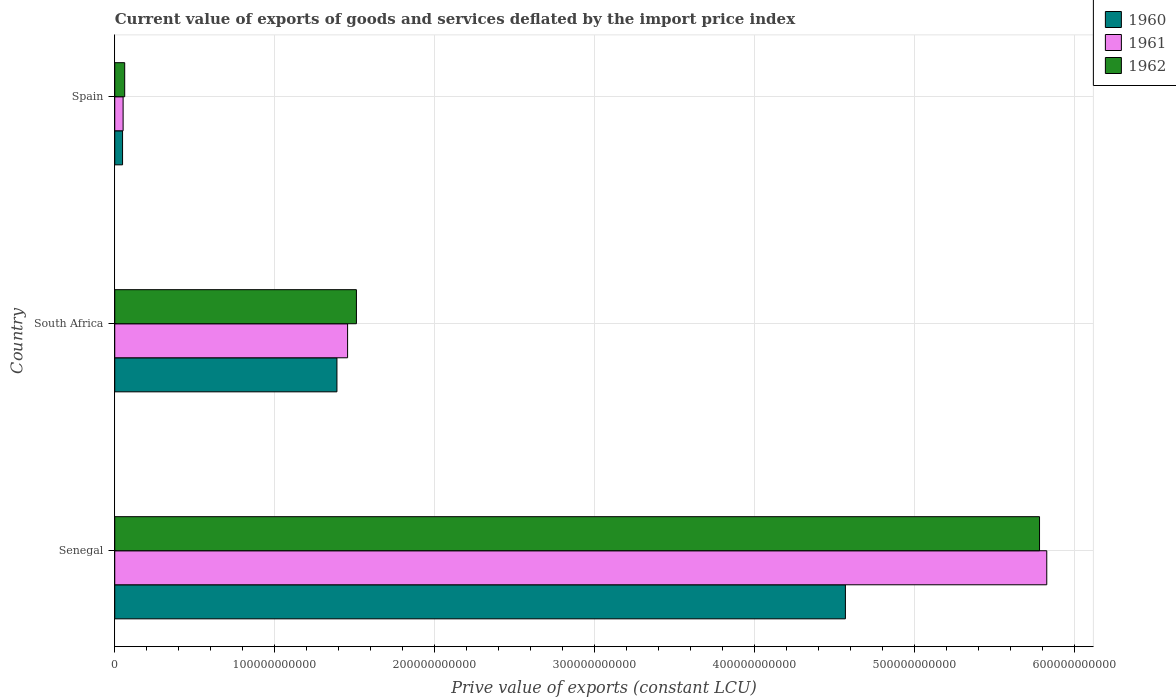How many different coloured bars are there?
Your response must be concise. 3. Are the number of bars per tick equal to the number of legend labels?
Offer a terse response. Yes. How many bars are there on the 3rd tick from the top?
Provide a succinct answer. 3. How many bars are there on the 2nd tick from the bottom?
Provide a succinct answer. 3. What is the label of the 3rd group of bars from the top?
Provide a short and direct response. Senegal. In how many cases, is the number of bars for a given country not equal to the number of legend labels?
Offer a terse response. 0. What is the prive value of exports in 1961 in Senegal?
Your response must be concise. 5.83e+11. Across all countries, what is the maximum prive value of exports in 1961?
Provide a short and direct response. 5.83e+11. Across all countries, what is the minimum prive value of exports in 1960?
Provide a succinct answer. 4.88e+09. In which country was the prive value of exports in 1961 maximum?
Provide a short and direct response. Senegal. In which country was the prive value of exports in 1960 minimum?
Your answer should be very brief. Spain. What is the total prive value of exports in 1961 in the graph?
Your answer should be compact. 7.34e+11. What is the difference between the prive value of exports in 1962 in South Africa and that in Spain?
Provide a succinct answer. 1.45e+11. What is the difference between the prive value of exports in 1962 in Spain and the prive value of exports in 1960 in South Africa?
Your response must be concise. -1.33e+11. What is the average prive value of exports in 1962 per country?
Ensure brevity in your answer.  2.45e+11. What is the difference between the prive value of exports in 1962 and prive value of exports in 1960 in Senegal?
Ensure brevity in your answer.  1.21e+11. In how many countries, is the prive value of exports in 1962 greater than 400000000000 LCU?
Offer a terse response. 1. What is the ratio of the prive value of exports in 1961 in South Africa to that in Spain?
Offer a very short reply. 27.86. What is the difference between the highest and the second highest prive value of exports in 1961?
Your response must be concise. 4.37e+11. What is the difference between the highest and the lowest prive value of exports in 1961?
Offer a very short reply. 5.77e+11. Is the sum of the prive value of exports in 1961 in Senegal and Spain greater than the maximum prive value of exports in 1960 across all countries?
Keep it short and to the point. Yes. What does the 3rd bar from the top in Senegal represents?
Your response must be concise. 1960. How many bars are there?
Your response must be concise. 9. Are all the bars in the graph horizontal?
Provide a short and direct response. Yes. How many countries are there in the graph?
Your answer should be compact. 3. What is the difference between two consecutive major ticks on the X-axis?
Ensure brevity in your answer.  1.00e+11. Are the values on the major ticks of X-axis written in scientific E-notation?
Offer a very short reply. No. Where does the legend appear in the graph?
Offer a terse response. Top right. How many legend labels are there?
Offer a terse response. 3. How are the legend labels stacked?
Offer a terse response. Vertical. What is the title of the graph?
Offer a terse response. Current value of exports of goods and services deflated by the import price index. What is the label or title of the X-axis?
Your answer should be compact. Prive value of exports (constant LCU). What is the label or title of the Y-axis?
Make the answer very short. Country. What is the Prive value of exports (constant LCU) of 1960 in Senegal?
Give a very brief answer. 4.57e+11. What is the Prive value of exports (constant LCU) of 1961 in Senegal?
Make the answer very short. 5.83e+11. What is the Prive value of exports (constant LCU) in 1962 in Senegal?
Keep it short and to the point. 5.78e+11. What is the Prive value of exports (constant LCU) of 1960 in South Africa?
Your answer should be very brief. 1.39e+11. What is the Prive value of exports (constant LCU) of 1961 in South Africa?
Ensure brevity in your answer.  1.46e+11. What is the Prive value of exports (constant LCU) of 1962 in South Africa?
Give a very brief answer. 1.51e+11. What is the Prive value of exports (constant LCU) in 1960 in Spain?
Make the answer very short. 4.88e+09. What is the Prive value of exports (constant LCU) in 1961 in Spain?
Your answer should be compact. 5.23e+09. What is the Prive value of exports (constant LCU) in 1962 in Spain?
Your answer should be very brief. 6.22e+09. Across all countries, what is the maximum Prive value of exports (constant LCU) in 1960?
Offer a very short reply. 4.57e+11. Across all countries, what is the maximum Prive value of exports (constant LCU) of 1961?
Provide a short and direct response. 5.83e+11. Across all countries, what is the maximum Prive value of exports (constant LCU) of 1962?
Offer a terse response. 5.78e+11. Across all countries, what is the minimum Prive value of exports (constant LCU) in 1960?
Offer a terse response. 4.88e+09. Across all countries, what is the minimum Prive value of exports (constant LCU) in 1961?
Provide a short and direct response. 5.23e+09. Across all countries, what is the minimum Prive value of exports (constant LCU) of 1962?
Provide a succinct answer. 6.22e+09. What is the total Prive value of exports (constant LCU) in 1960 in the graph?
Provide a short and direct response. 6.01e+11. What is the total Prive value of exports (constant LCU) of 1961 in the graph?
Ensure brevity in your answer.  7.34e+11. What is the total Prive value of exports (constant LCU) in 1962 in the graph?
Your answer should be compact. 7.36e+11. What is the difference between the Prive value of exports (constant LCU) of 1960 in Senegal and that in South Africa?
Provide a succinct answer. 3.18e+11. What is the difference between the Prive value of exports (constant LCU) of 1961 in Senegal and that in South Africa?
Your answer should be compact. 4.37e+11. What is the difference between the Prive value of exports (constant LCU) in 1962 in Senegal and that in South Africa?
Your response must be concise. 4.27e+11. What is the difference between the Prive value of exports (constant LCU) in 1960 in Senegal and that in Spain?
Offer a terse response. 4.52e+11. What is the difference between the Prive value of exports (constant LCU) in 1961 in Senegal and that in Spain?
Ensure brevity in your answer.  5.77e+11. What is the difference between the Prive value of exports (constant LCU) in 1962 in Senegal and that in Spain?
Your answer should be compact. 5.72e+11. What is the difference between the Prive value of exports (constant LCU) in 1960 in South Africa and that in Spain?
Offer a very short reply. 1.34e+11. What is the difference between the Prive value of exports (constant LCU) of 1961 in South Africa and that in Spain?
Ensure brevity in your answer.  1.40e+11. What is the difference between the Prive value of exports (constant LCU) of 1962 in South Africa and that in Spain?
Your answer should be very brief. 1.45e+11. What is the difference between the Prive value of exports (constant LCU) in 1960 in Senegal and the Prive value of exports (constant LCU) in 1961 in South Africa?
Provide a succinct answer. 3.11e+11. What is the difference between the Prive value of exports (constant LCU) in 1960 in Senegal and the Prive value of exports (constant LCU) in 1962 in South Africa?
Offer a very short reply. 3.06e+11. What is the difference between the Prive value of exports (constant LCU) of 1961 in Senegal and the Prive value of exports (constant LCU) of 1962 in South Africa?
Your answer should be compact. 4.32e+11. What is the difference between the Prive value of exports (constant LCU) of 1960 in Senegal and the Prive value of exports (constant LCU) of 1961 in Spain?
Give a very brief answer. 4.52e+11. What is the difference between the Prive value of exports (constant LCU) in 1960 in Senegal and the Prive value of exports (constant LCU) in 1962 in Spain?
Your answer should be very brief. 4.51e+11. What is the difference between the Prive value of exports (constant LCU) in 1961 in Senegal and the Prive value of exports (constant LCU) in 1962 in Spain?
Your answer should be very brief. 5.77e+11. What is the difference between the Prive value of exports (constant LCU) in 1960 in South Africa and the Prive value of exports (constant LCU) in 1961 in Spain?
Make the answer very short. 1.34e+11. What is the difference between the Prive value of exports (constant LCU) of 1960 in South Africa and the Prive value of exports (constant LCU) of 1962 in Spain?
Ensure brevity in your answer.  1.33e+11. What is the difference between the Prive value of exports (constant LCU) of 1961 in South Africa and the Prive value of exports (constant LCU) of 1962 in Spain?
Provide a short and direct response. 1.39e+11. What is the average Prive value of exports (constant LCU) of 1960 per country?
Keep it short and to the point. 2.00e+11. What is the average Prive value of exports (constant LCU) in 1961 per country?
Keep it short and to the point. 2.45e+11. What is the average Prive value of exports (constant LCU) in 1962 per country?
Make the answer very short. 2.45e+11. What is the difference between the Prive value of exports (constant LCU) in 1960 and Prive value of exports (constant LCU) in 1961 in Senegal?
Your answer should be very brief. -1.26e+11. What is the difference between the Prive value of exports (constant LCU) of 1960 and Prive value of exports (constant LCU) of 1962 in Senegal?
Provide a succinct answer. -1.21e+11. What is the difference between the Prive value of exports (constant LCU) in 1961 and Prive value of exports (constant LCU) in 1962 in Senegal?
Offer a terse response. 4.52e+09. What is the difference between the Prive value of exports (constant LCU) in 1960 and Prive value of exports (constant LCU) in 1961 in South Africa?
Offer a terse response. -6.66e+09. What is the difference between the Prive value of exports (constant LCU) in 1960 and Prive value of exports (constant LCU) in 1962 in South Africa?
Keep it short and to the point. -1.22e+1. What is the difference between the Prive value of exports (constant LCU) of 1961 and Prive value of exports (constant LCU) of 1962 in South Africa?
Your answer should be very brief. -5.52e+09. What is the difference between the Prive value of exports (constant LCU) of 1960 and Prive value of exports (constant LCU) of 1961 in Spain?
Make the answer very short. -3.48e+08. What is the difference between the Prive value of exports (constant LCU) in 1960 and Prive value of exports (constant LCU) in 1962 in Spain?
Provide a succinct answer. -1.34e+09. What is the difference between the Prive value of exports (constant LCU) in 1961 and Prive value of exports (constant LCU) in 1962 in Spain?
Ensure brevity in your answer.  -9.94e+08. What is the ratio of the Prive value of exports (constant LCU) of 1960 in Senegal to that in South Africa?
Your response must be concise. 3.29. What is the ratio of the Prive value of exports (constant LCU) of 1961 in Senegal to that in South Africa?
Your response must be concise. 4. What is the ratio of the Prive value of exports (constant LCU) in 1962 in Senegal to that in South Africa?
Keep it short and to the point. 3.83. What is the ratio of the Prive value of exports (constant LCU) of 1960 in Senegal to that in Spain?
Make the answer very short. 93.66. What is the ratio of the Prive value of exports (constant LCU) in 1961 in Senegal to that in Spain?
Give a very brief answer. 111.52. What is the ratio of the Prive value of exports (constant LCU) of 1962 in Senegal to that in Spain?
Offer a very short reply. 92.97. What is the ratio of the Prive value of exports (constant LCU) of 1960 in South Africa to that in Spain?
Your answer should be very brief. 28.48. What is the ratio of the Prive value of exports (constant LCU) of 1961 in South Africa to that in Spain?
Your answer should be compact. 27.86. What is the ratio of the Prive value of exports (constant LCU) of 1962 in South Africa to that in Spain?
Your answer should be very brief. 24.29. What is the difference between the highest and the second highest Prive value of exports (constant LCU) of 1960?
Provide a succinct answer. 3.18e+11. What is the difference between the highest and the second highest Prive value of exports (constant LCU) of 1961?
Ensure brevity in your answer.  4.37e+11. What is the difference between the highest and the second highest Prive value of exports (constant LCU) in 1962?
Make the answer very short. 4.27e+11. What is the difference between the highest and the lowest Prive value of exports (constant LCU) of 1960?
Keep it short and to the point. 4.52e+11. What is the difference between the highest and the lowest Prive value of exports (constant LCU) in 1961?
Keep it short and to the point. 5.77e+11. What is the difference between the highest and the lowest Prive value of exports (constant LCU) of 1962?
Offer a terse response. 5.72e+11. 